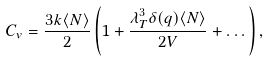<formula> <loc_0><loc_0><loc_500><loc_500>C _ { v } = \frac { 3 k \langle N \rangle } { 2 } \left ( 1 + \frac { \lambda _ { T } ^ { 3 } \delta ( q ) \langle N \rangle } { 2 V } + \dots \right ) ,</formula> 